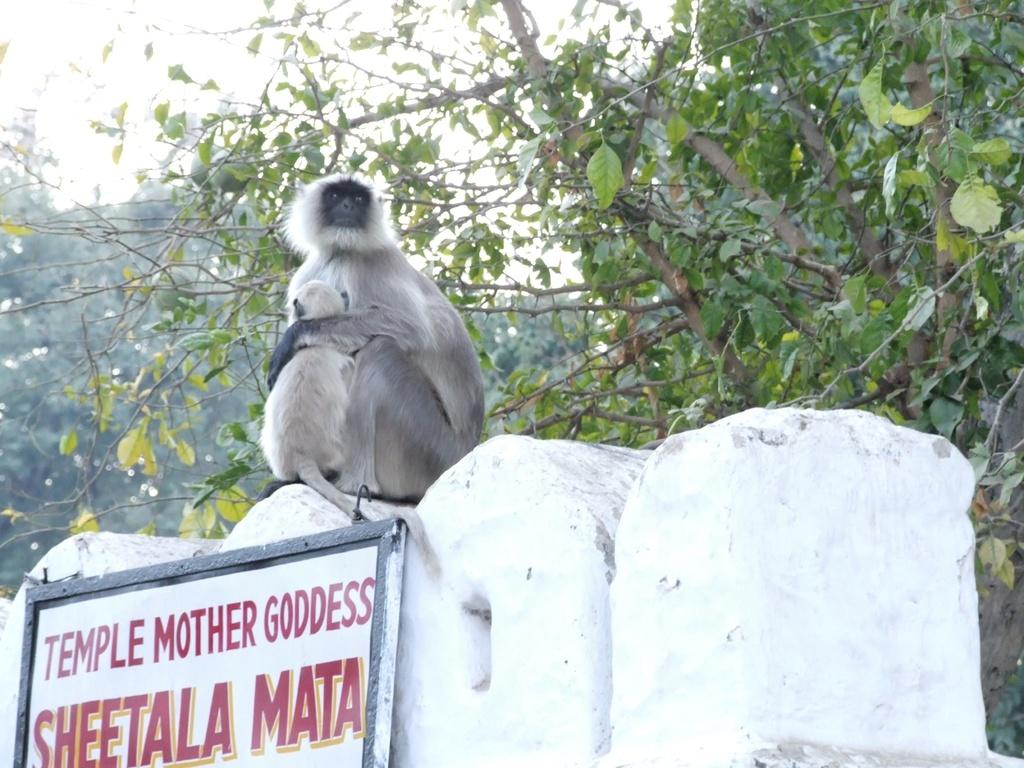How many monkeys are in the image? There are two monkeys in the image. Where are the monkeys located? The monkeys are sitting on a temple wall. What can be seen in the background of the image? Many branches of a tree are visible in the image. What type of baseball equipment can be seen in the image? There is no baseball equipment present in the image. How many bears are visible in the image? There are no bears present in the image. 